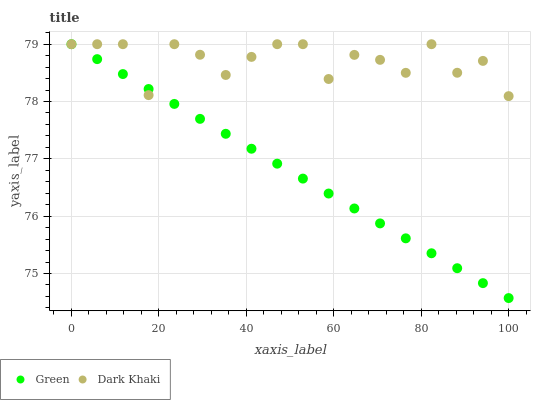Does Green have the minimum area under the curve?
Answer yes or no. Yes. Does Dark Khaki have the maximum area under the curve?
Answer yes or no. Yes. Does Green have the maximum area under the curve?
Answer yes or no. No. Is Green the smoothest?
Answer yes or no. Yes. Is Dark Khaki the roughest?
Answer yes or no. Yes. Is Green the roughest?
Answer yes or no. No. Does Green have the lowest value?
Answer yes or no. Yes. Does Green have the highest value?
Answer yes or no. Yes. Does Green intersect Dark Khaki?
Answer yes or no. Yes. Is Green less than Dark Khaki?
Answer yes or no. No. Is Green greater than Dark Khaki?
Answer yes or no. No. 